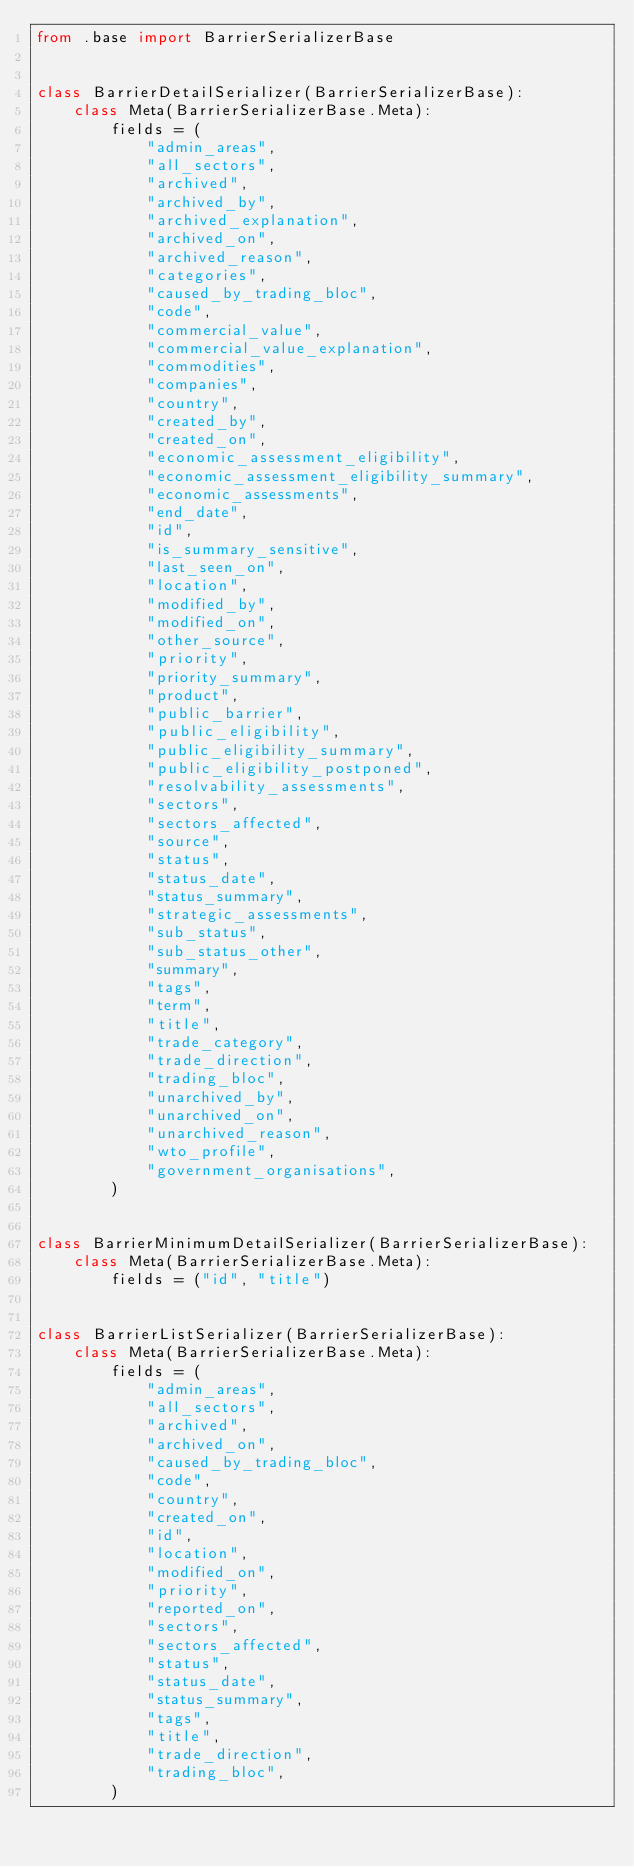Convert code to text. <code><loc_0><loc_0><loc_500><loc_500><_Python_>from .base import BarrierSerializerBase


class BarrierDetailSerializer(BarrierSerializerBase):
    class Meta(BarrierSerializerBase.Meta):
        fields = (
            "admin_areas",
            "all_sectors",
            "archived",
            "archived_by",
            "archived_explanation",
            "archived_on",
            "archived_reason",
            "categories",
            "caused_by_trading_bloc",
            "code",
            "commercial_value",
            "commercial_value_explanation",
            "commodities",
            "companies",
            "country",
            "created_by",
            "created_on",
            "economic_assessment_eligibility",
            "economic_assessment_eligibility_summary",
            "economic_assessments",
            "end_date",
            "id",
            "is_summary_sensitive",
            "last_seen_on",
            "location",
            "modified_by",
            "modified_on",
            "other_source",
            "priority",
            "priority_summary",
            "product",
            "public_barrier",
            "public_eligibility",
            "public_eligibility_summary",
            "public_eligibility_postponed",
            "resolvability_assessments",
            "sectors",
            "sectors_affected",
            "source",
            "status",
            "status_date",
            "status_summary",
            "strategic_assessments",
            "sub_status",
            "sub_status_other",
            "summary",
            "tags",
            "term",
            "title",
            "trade_category",
            "trade_direction",
            "trading_bloc",
            "unarchived_by",
            "unarchived_on",
            "unarchived_reason",
            "wto_profile",
            "government_organisations",
        )


class BarrierMinimumDetailSerializer(BarrierSerializerBase):
    class Meta(BarrierSerializerBase.Meta):
        fields = ("id", "title")


class BarrierListSerializer(BarrierSerializerBase):
    class Meta(BarrierSerializerBase.Meta):
        fields = (
            "admin_areas",
            "all_sectors",
            "archived",
            "archived_on",
            "caused_by_trading_bloc",
            "code",
            "country",
            "created_on",
            "id",
            "location",
            "modified_on",
            "priority",
            "reported_on",
            "sectors",
            "sectors_affected",
            "status",
            "status_date",
            "status_summary",
            "tags",
            "title",
            "trade_direction",
            "trading_bloc",
        )
</code> 